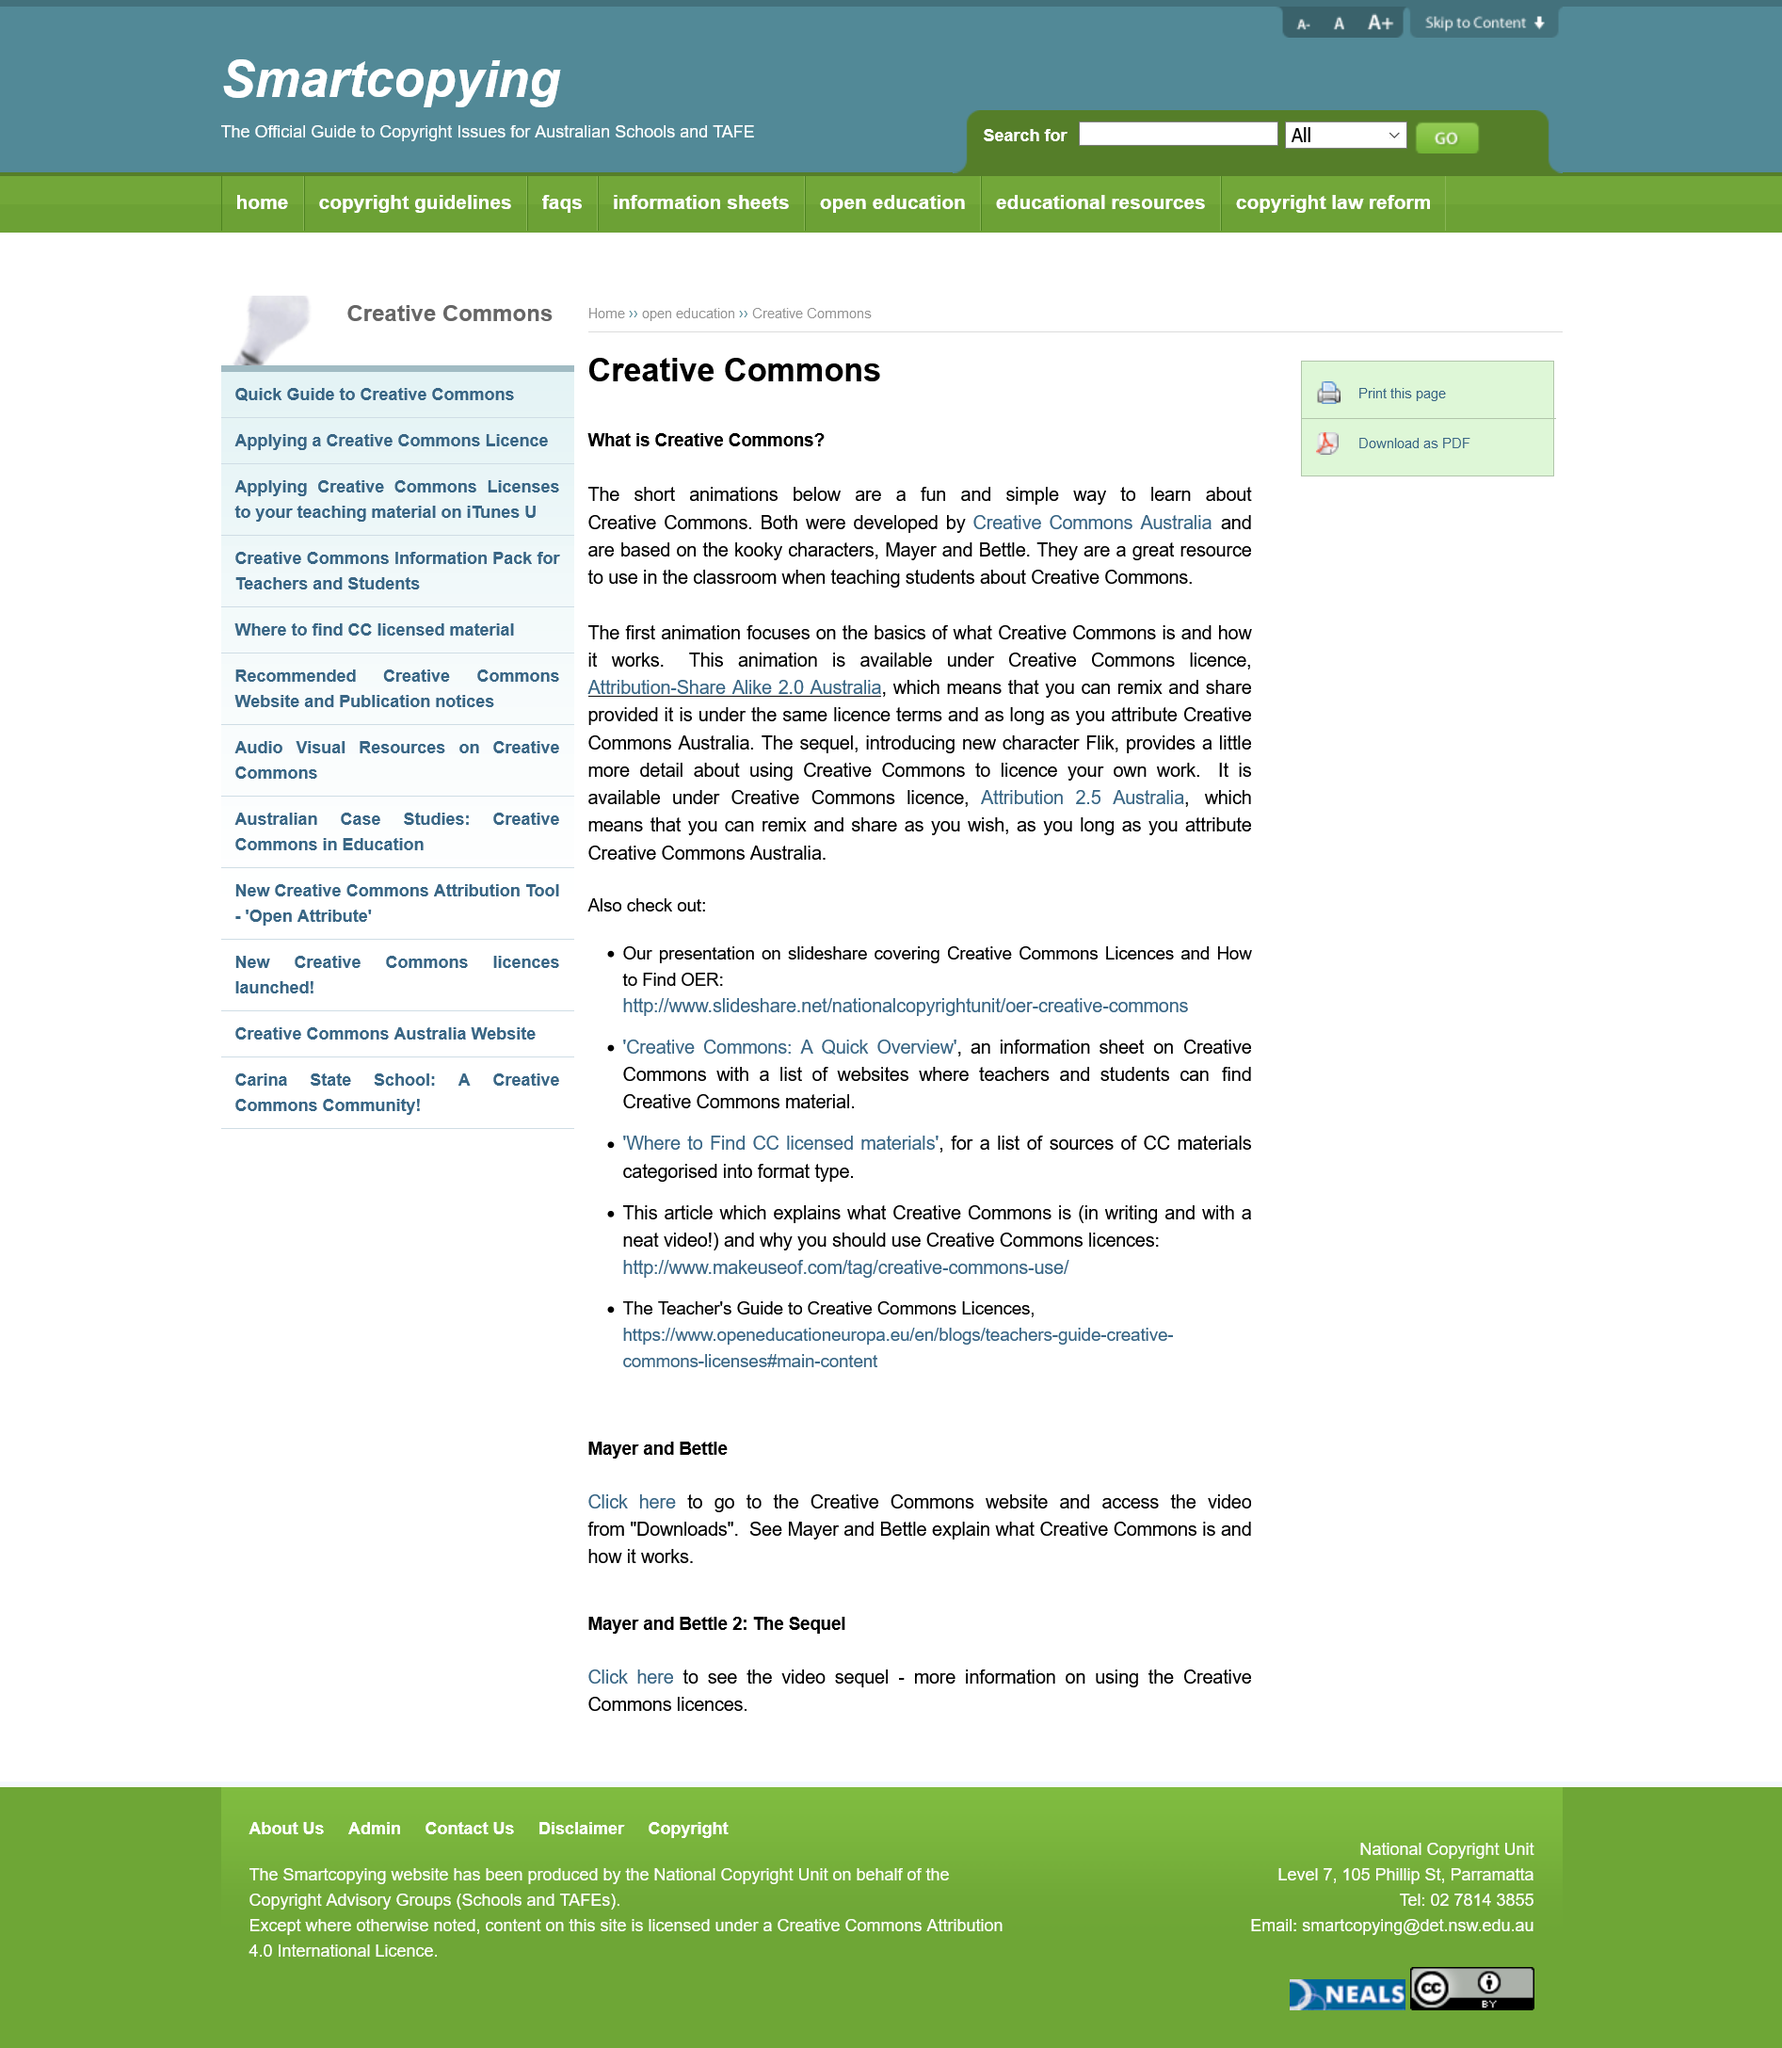Give some essential details in this illustration. I am permitted to share and remix the animation, as long as I attribute Creative Commons Australia and follow the conditions of the license. In order to use the animations, you must attribute Creative Commons Australia. The animations feature three characters named Mayer, Bettle, and Flik. 